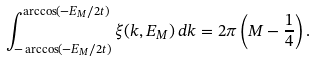Convert formula to latex. <formula><loc_0><loc_0><loc_500><loc_500>\int _ { - \arccos ( - E _ { M } / 2 t ) } ^ { \arccos ( - E _ { M } / 2 t ) } \xi ( k , E _ { M } ) \, d k = 2 \pi \left ( M - \frac { 1 } { 4 } \right ) .</formula> 